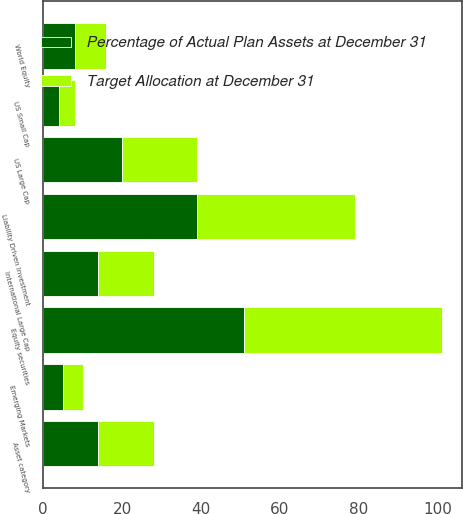<chart> <loc_0><loc_0><loc_500><loc_500><stacked_bar_chart><ecel><fcel>Asset category<fcel>US Large Cap<fcel>US Small Cap<fcel>International Large Cap<fcel>Emerging Markets<fcel>World Equity<fcel>Equity securities<fcel>Liability Driven Investment<nl><fcel>Target Allocation at December 31<fcel>14<fcel>19<fcel>4<fcel>14<fcel>5<fcel>8<fcel>50<fcel>40<nl><fcel>Percentage of Actual Plan Assets at December 31<fcel>14<fcel>20<fcel>4<fcel>14<fcel>5<fcel>8<fcel>51<fcel>39<nl></chart> 